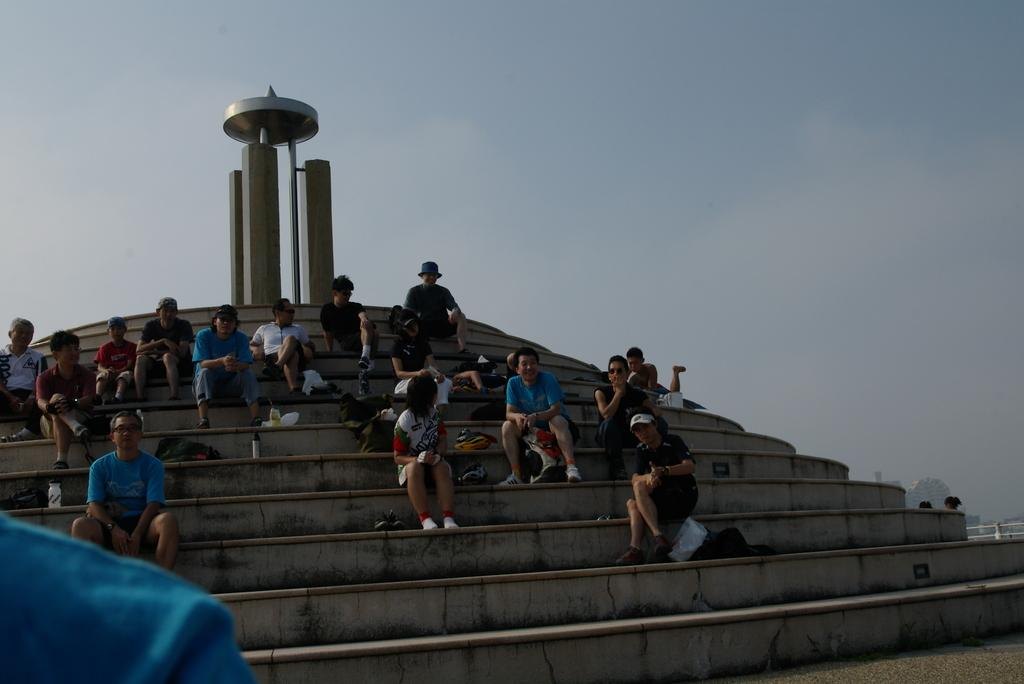What are the people in the image doing? The people in the image are sitting on a staircase. What other architectural feature can be seen in the image? There is a pillar-like structure visible in the image. What type of sack can be seen being carried by the people in the image? There is no sack visible in the image; the people are simply sitting on the staircase. 